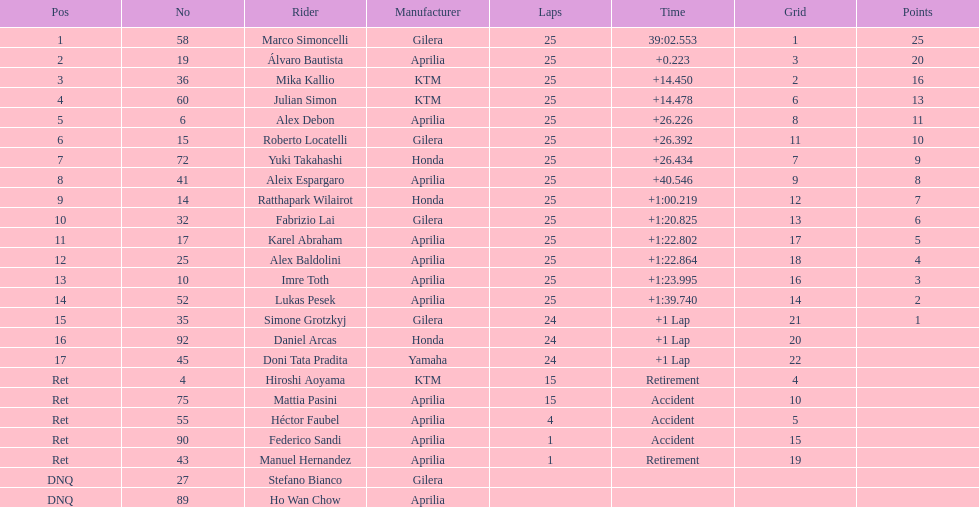How many riders manufacturer is honda? 3. 